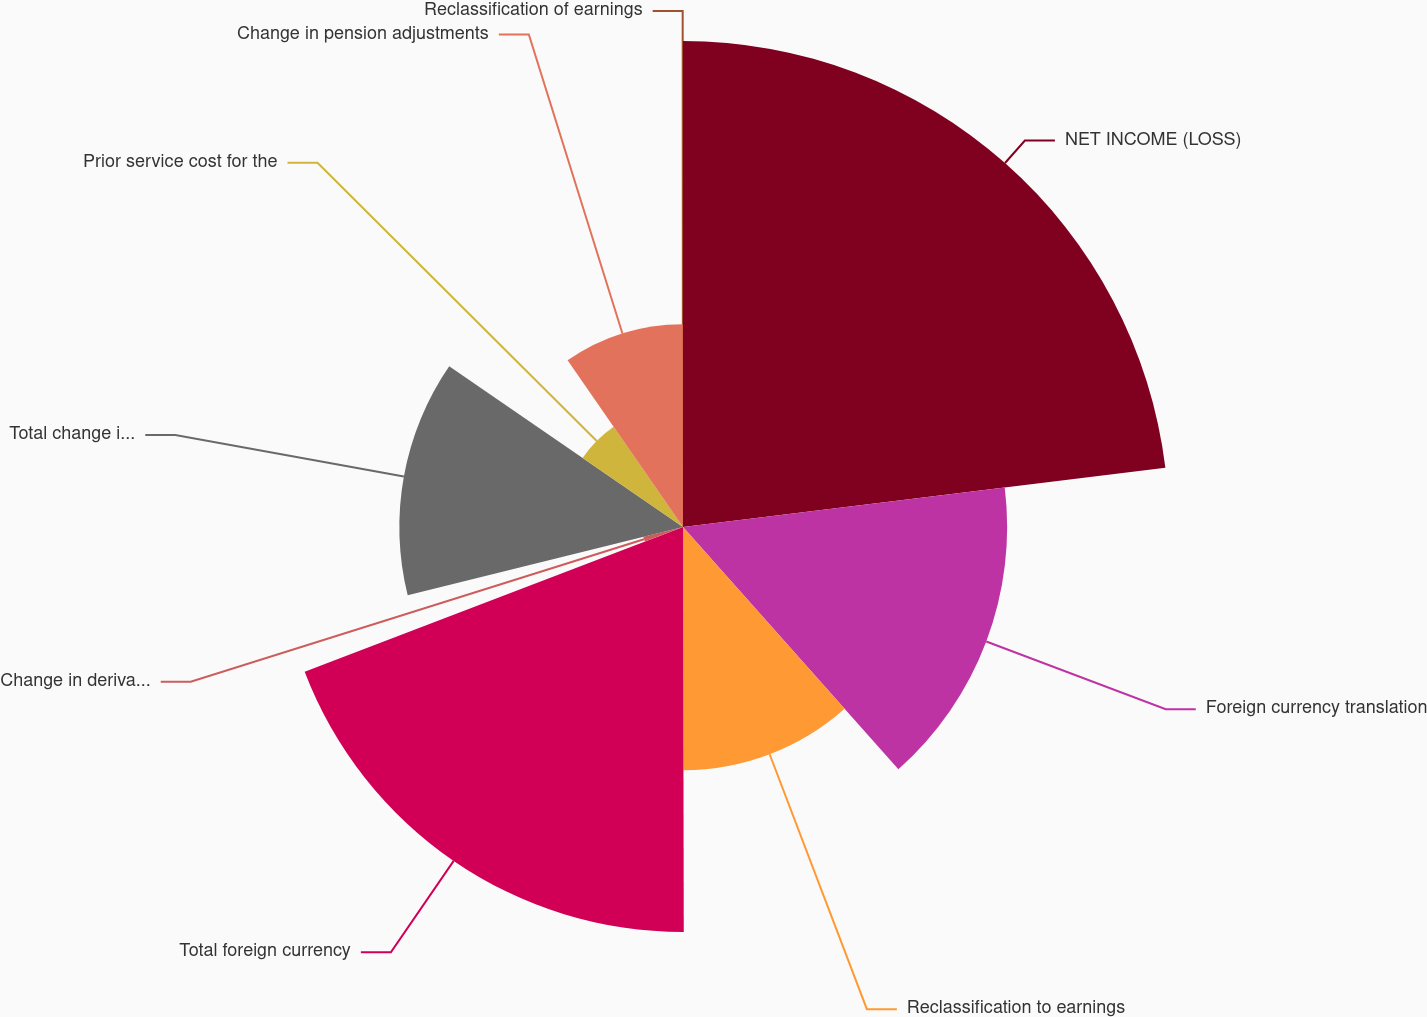<chart> <loc_0><loc_0><loc_500><loc_500><pie_chart><fcel>NET INCOME (LOSS)<fcel>Foreign currency translation<fcel>Reclassification to earnings<fcel>Total foreign currency<fcel>Change in derivative fair<fcel>Total change in fair value of<fcel>Prior service cost for the<fcel>Change in pension adjustments<fcel>Reclassification of earnings<nl><fcel>23.06%<fcel>15.38%<fcel>11.54%<fcel>19.22%<fcel>1.94%<fcel>13.46%<fcel>5.78%<fcel>9.62%<fcel>0.02%<nl></chart> 